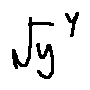Convert formula to latex. <formula><loc_0><loc_0><loc_500><loc_500>\sqrt { y } ^ { y }</formula> 